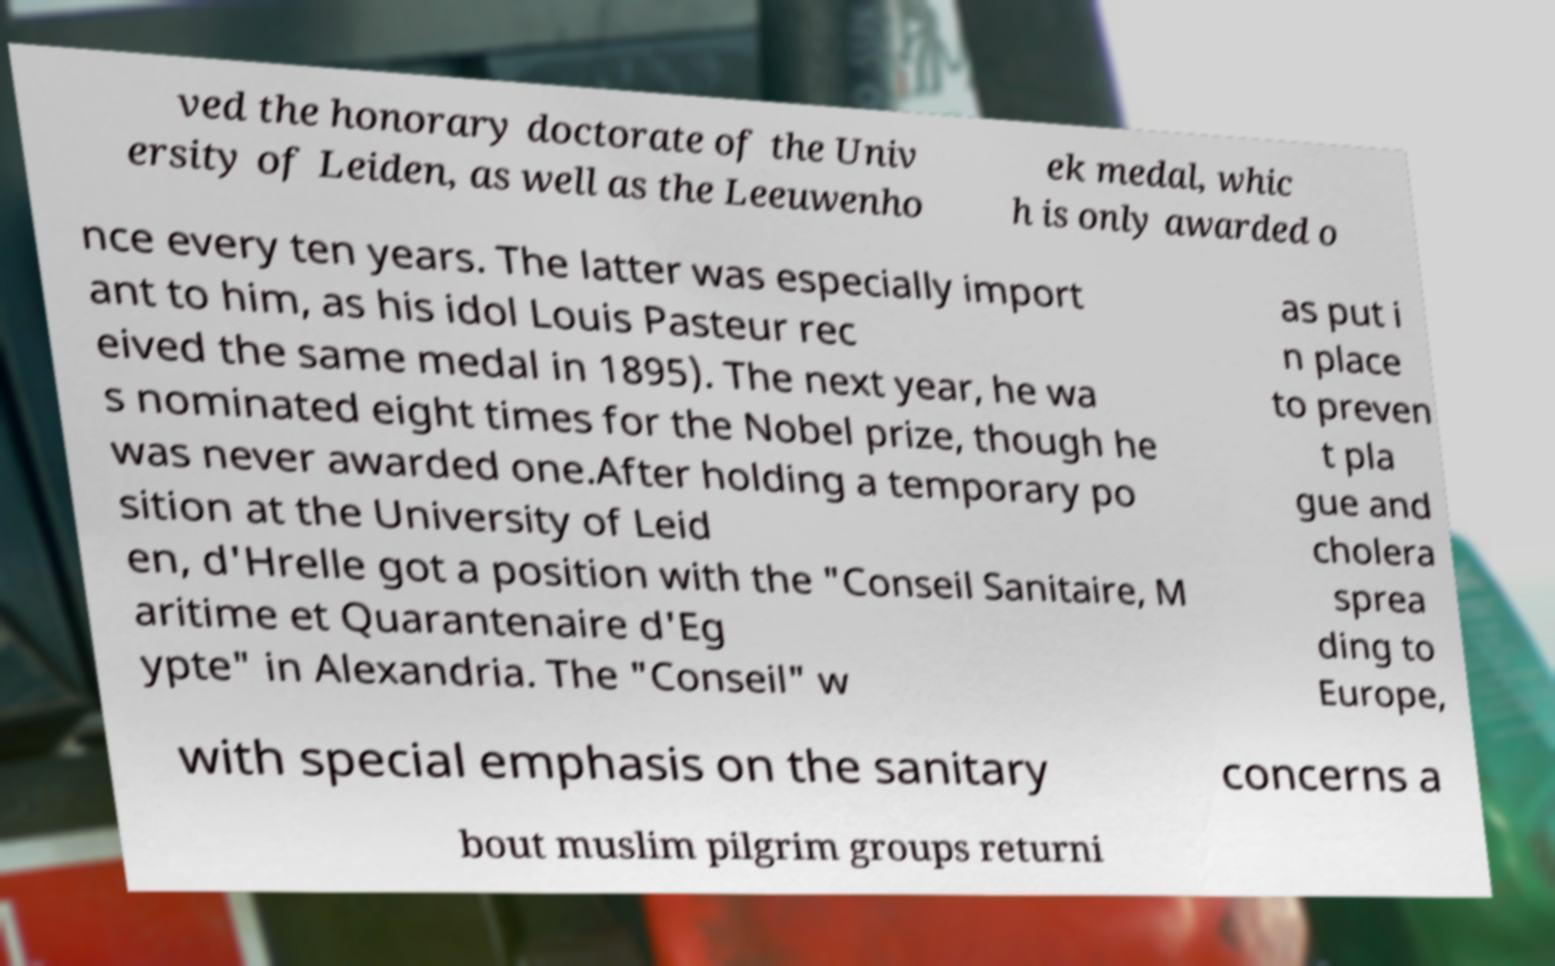Can you read and provide the text displayed in the image?This photo seems to have some interesting text. Can you extract and type it out for me? ved the honorary doctorate of the Univ ersity of Leiden, as well as the Leeuwenho ek medal, whic h is only awarded o nce every ten years. The latter was especially import ant to him, as his idol Louis Pasteur rec eived the same medal in 1895). The next year, he wa s nominated eight times for the Nobel prize, though he was never awarded one.After holding a temporary po sition at the University of Leid en, d'Hrelle got a position with the "Conseil Sanitaire, M aritime et Quarantenaire d'Eg ypte" in Alexandria. The "Conseil" w as put i n place to preven t pla gue and cholera sprea ding to Europe, with special emphasis on the sanitary concerns a bout muslim pilgrim groups returni 